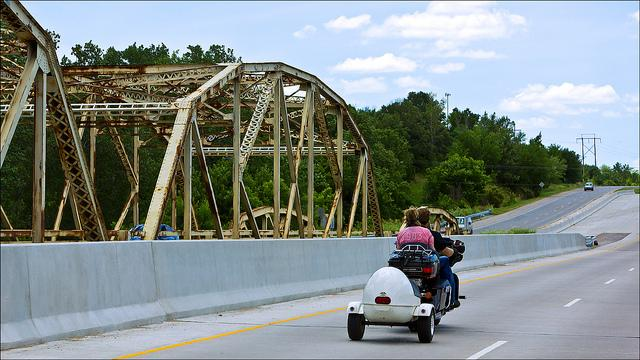What is next to the vehicle? bridge 